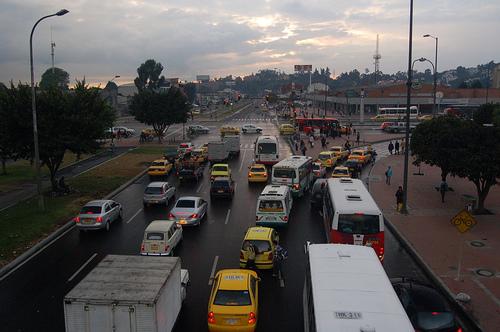Is the sky clear and sunny?
Write a very short answer. No. Why are all the white vans lined along the road?
Be succinct. Traffic. What color is the bike sign?
Quick response, please. Yellow. Is there a traffic jam?
Short answer required. Yes. 